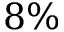<formula> <loc_0><loc_0><loc_500><loc_500>8 \%</formula> 